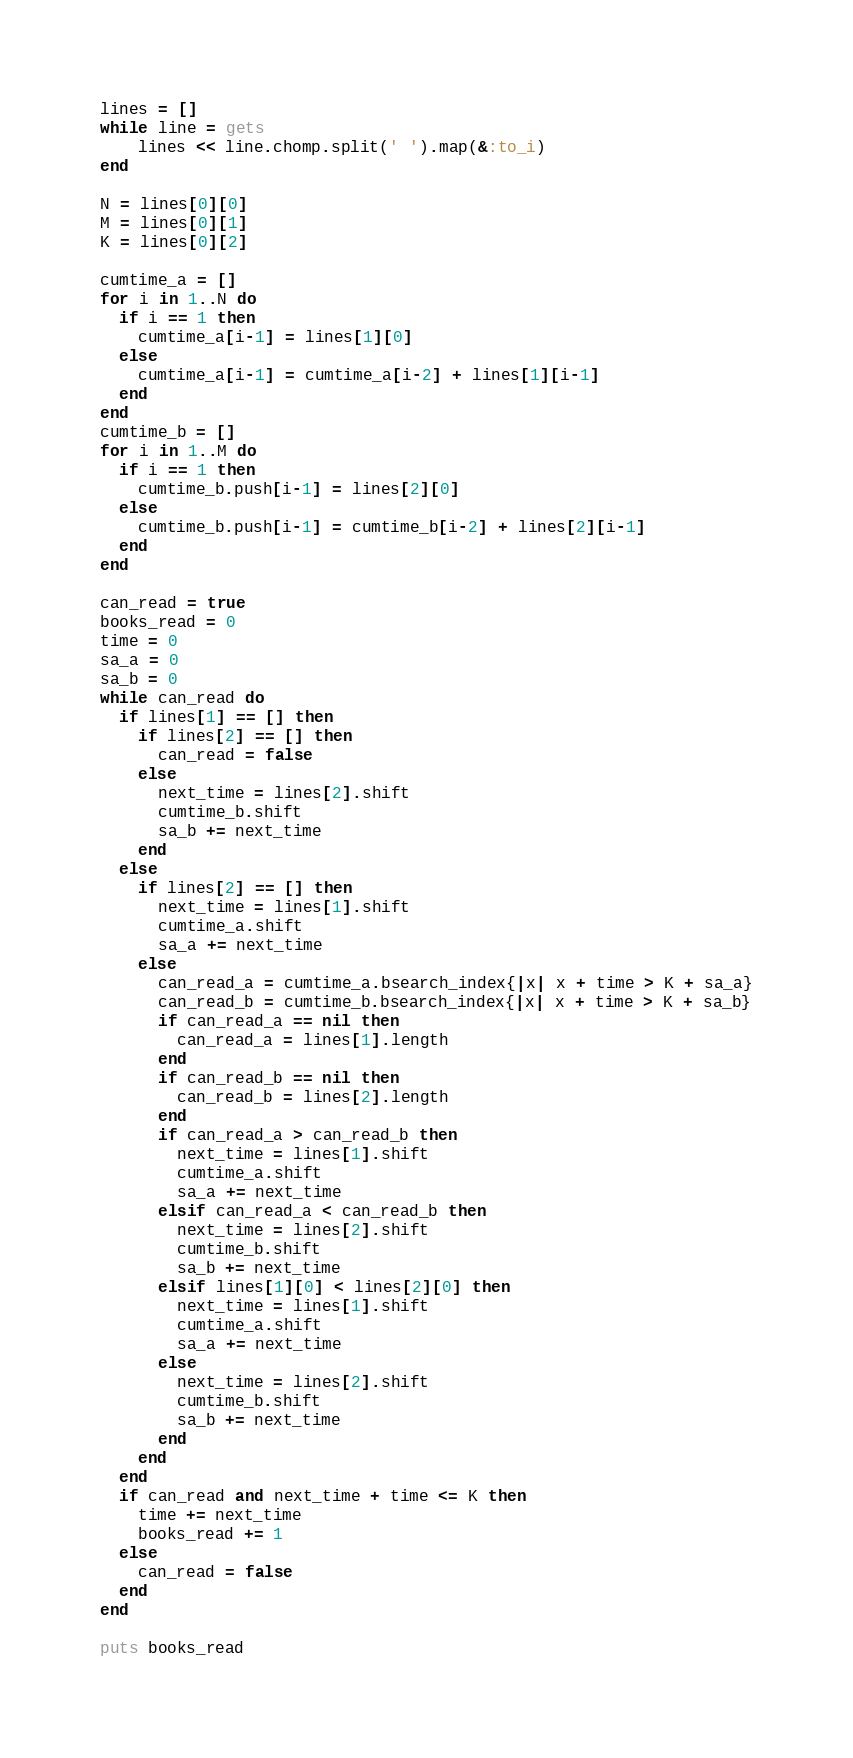Convert code to text. <code><loc_0><loc_0><loc_500><loc_500><_Ruby_>lines = []
while line = gets
    lines << line.chomp.split(' ').map(&:to_i)
end

N = lines[0][0]
M = lines[0][1]
K = lines[0][2]

cumtime_a = []
for i in 1..N do
  if i == 1 then
    cumtime_a[i-1] = lines[1][0]
  else
    cumtime_a[i-1] = cumtime_a[i-2] + lines[1][i-1]
  end
end
cumtime_b = []
for i in 1..M do
  if i == 1 then
    cumtime_b.push[i-1] = lines[2][0]
  else
    cumtime_b.push[i-1] = cumtime_b[i-2] + lines[2][i-1]
  end
end
  
can_read = true
books_read = 0
time = 0
sa_a = 0
sa_b = 0
while can_read do
  if lines[1] == [] then
    if lines[2] == [] then
      can_read = false
    else
      next_time = lines[2].shift
      cumtime_b.shift
      sa_b += next_time
    end
  else
    if lines[2] == [] then
      next_time = lines[1].shift
      cumtime_a.shift
      sa_a += next_time
    else
      can_read_a = cumtime_a.bsearch_index{|x| x + time > K + sa_a}
      can_read_b = cumtime_b.bsearch_index{|x| x + time > K + sa_b}
      if can_read_a == nil then
        can_read_a = lines[1].length
      end
      if can_read_b == nil then
        can_read_b = lines[2].length
      end
      if can_read_a > can_read_b then
        next_time = lines[1].shift
        cumtime_a.shift
        sa_a += next_time
      elsif can_read_a < can_read_b then
        next_time = lines[2].shift
        cumtime_b.shift
        sa_b += next_time
      elsif lines[1][0] < lines[2][0] then
        next_time = lines[1].shift
        cumtime_a.shift
        sa_a += next_time
      else
        next_time = lines[2].shift
        cumtime_b.shift
        sa_b += next_time
      end
    end
  end
  if can_read and next_time + time <= K then
    time += next_time
    books_read += 1
  else
    can_read = false
  end
end
      
puts books_read</code> 